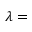Convert formula to latex. <formula><loc_0><loc_0><loc_500><loc_500>\lambda =</formula> 